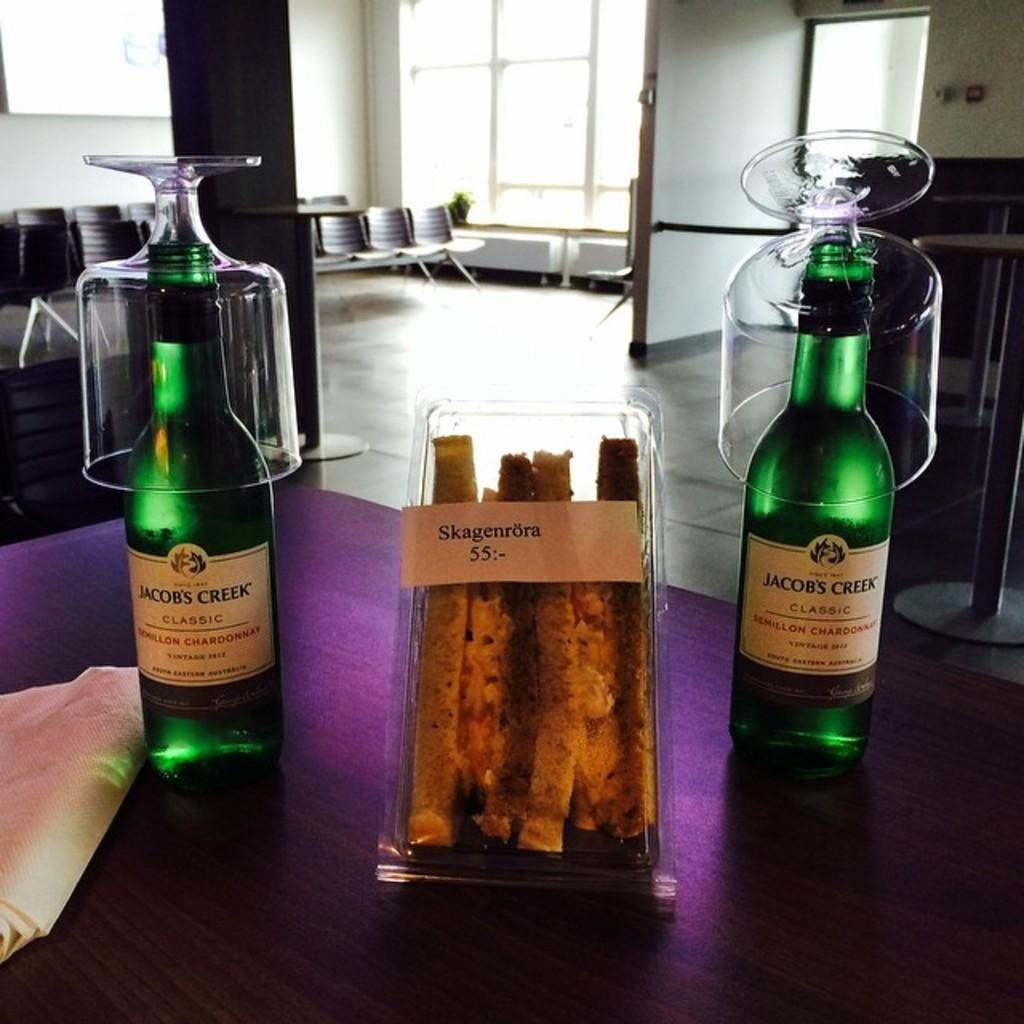Provide a one-sentence caption for the provided image. two beer bottles that say Jacob's Creek on them. 